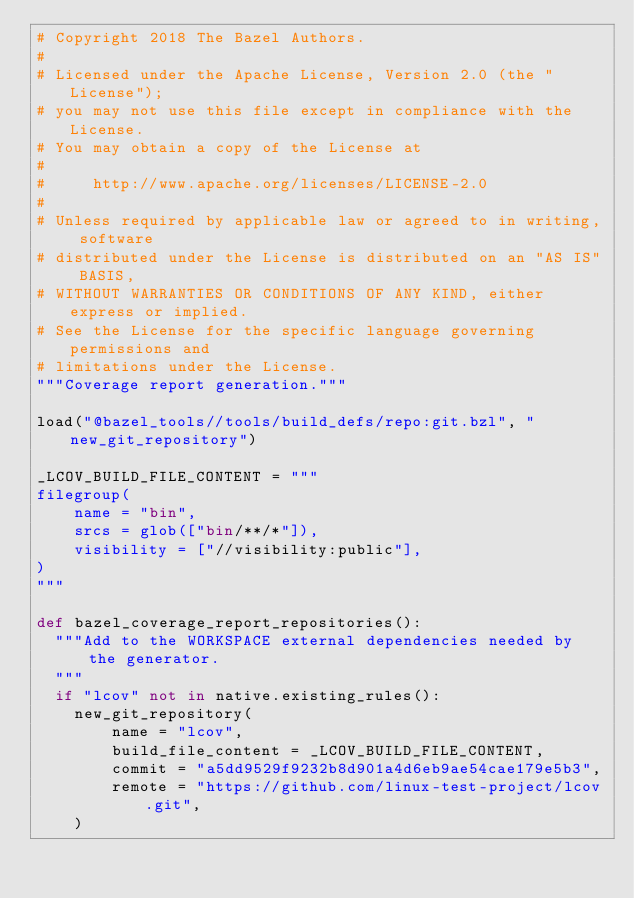<code> <loc_0><loc_0><loc_500><loc_500><_Python_># Copyright 2018 The Bazel Authors.
#
# Licensed under the Apache License, Version 2.0 (the "License");
# you may not use this file except in compliance with the License.
# You may obtain a copy of the License at
#
#     http://www.apache.org/licenses/LICENSE-2.0
#
# Unless required by applicable law or agreed to in writing, software
# distributed under the License is distributed on an "AS IS" BASIS,
# WITHOUT WARRANTIES OR CONDITIONS OF ANY KIND, either express or implied.
# See the License for the specific language governing permissions and
# limitations under the License.
"""Coverage report generation."""

load("@bazel_tools//tools/build_defs/repo:git.bzl", "new_git_repository")

_LCOV_BUILD_FILE_CONTENT = """
filegroup(
    name = "bin",
    srcs = glob(["bin/**/*"]),
    visibility = ["//visibility:public"],
)
"""

def bazel_coverage_report_repositories():
  """Add to the WORKSPACE external dependencies needed by the generator.
  """
  if "lcov" not in native.existing_rules():
    new_git_repository(
        name = "lcov",
        build_file_content = _LCOV_BUILD_FILE_CONTENT,
        commit = "a5dd9529f9232b8d901a4d6eb9ae54cae179e5b3",
        remote = "https://github.com/linux-test-project/lcov.git",
    )
</code> 